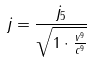Convert formula to latex. <formula><loc_0><loc_0><loc_500><loc_500>j = \frac { j _ { 5 } } { \sqrt { 1 \cdot \frac { v ^ { 9 } } { c ^ { 9 } } } }</formula> 